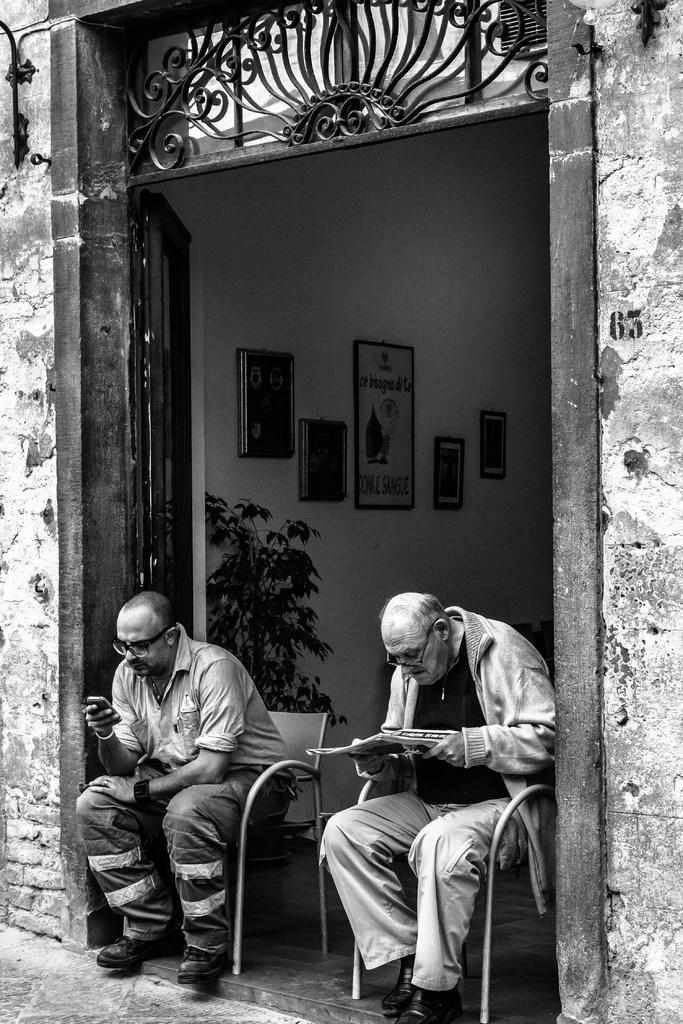Could you give a brief overview of what you see in this image? This is a black and white image. In this image we can see person sitting on the chairs, door, wall, plants and photo frames. 